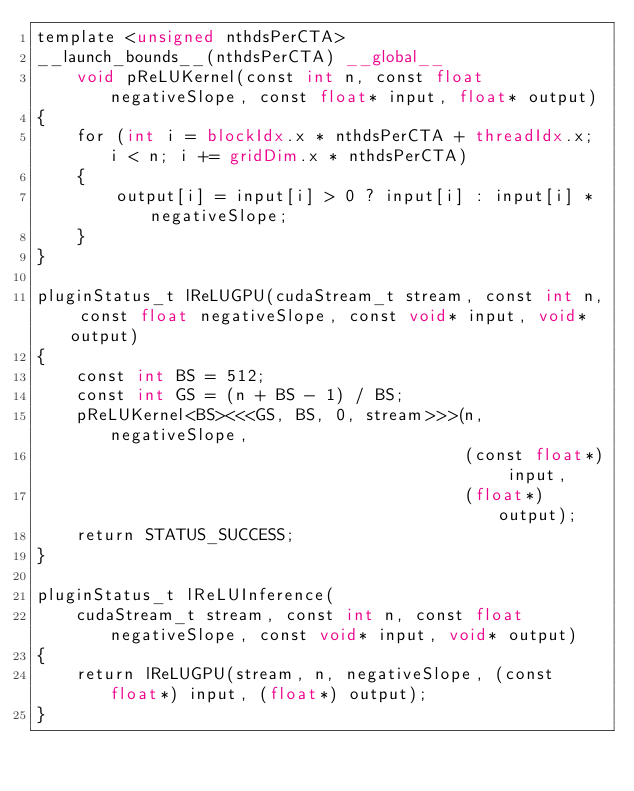<code> <loc_0><loc_0><loc_500><loc_500><_Cuda_>template <unsigned nthdsPerCTA>
__launch_bounds__(nthdsPerCTA) __global__
    void pReLUKernel(const int n, const float negativeSlope, const float* input, float* output)
{
    for (int i = blockIdx.x * nthdsPerCTA + threadIdx.x; i < n; i += gridDim.x * nthdsPerCTA)
    {
        output[i] = input[i] > 0 ? input[i] : input[i] * negativeSlope;
    }
}

pluginStatus_t lReLUGPU(cudaStream_t stream, const int n, const float negativeSlope, const void* input, void* output)
{
    const int BS = 512;
    const int GS = (n + BS - 1) / BS;
    pReLUKernel<BS><<<GS, BS, 0, stream>>>(n, negativeSlope,
                                           (const float*) input,
                                           (float*) output);
    return STATUS_SUCCESS;
}

pluginStatus_t lReLUInference(
    cudaStream_t stream, const int n, const float negativeSlope, const void* input, void* output)
{
    return lReLUGPU(stream, n, negativeSlope, (const float*) input, (float*) output);
}
</code> 